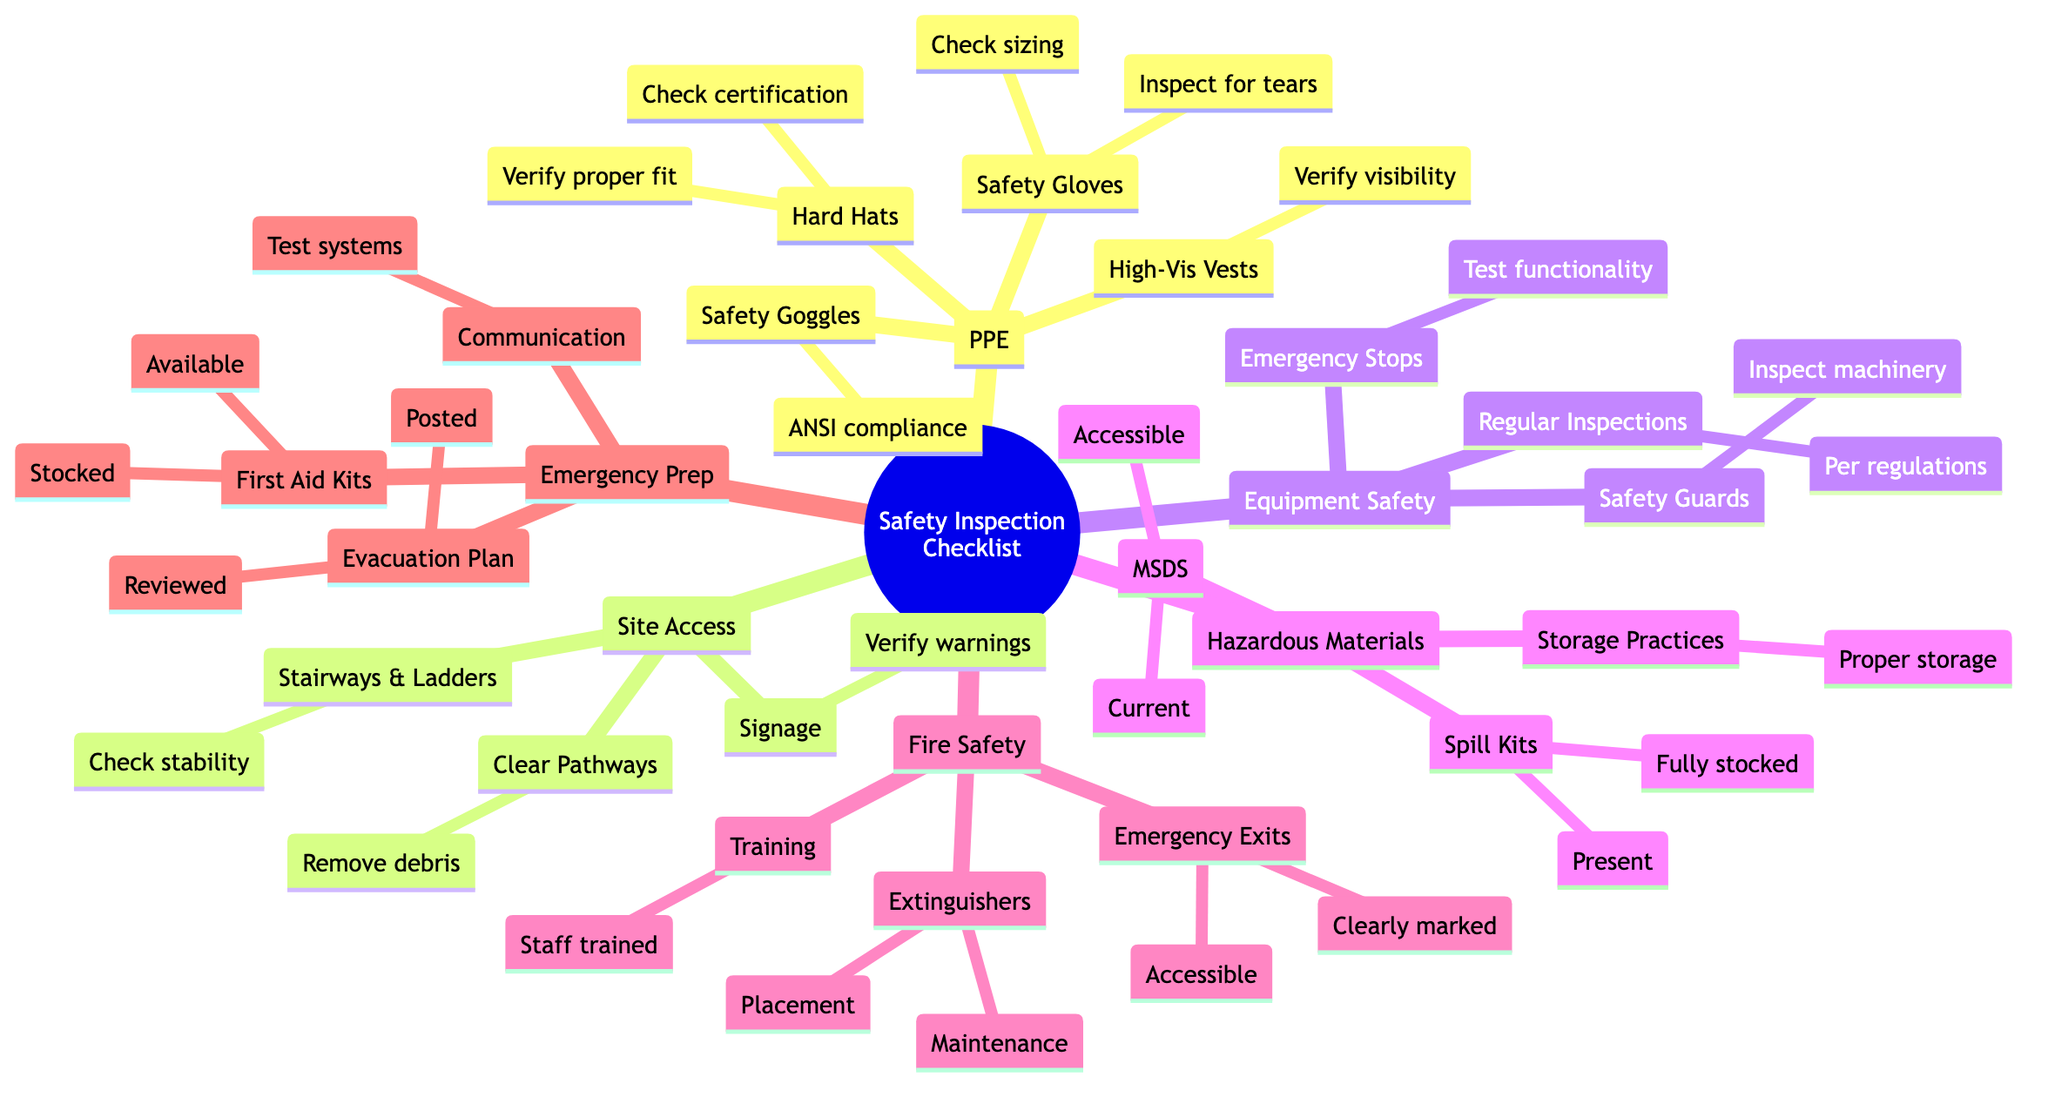What are the four main categories of the safety inspection checklist? The diagram lists the following main categories: Personal Protective Equipment, Site Access and Walkways, Equipment Safety, Hazardous Materials, Fire Safety, and Emergency Preparedness. These represent the top-level nodes of the mind map.
Answer: Personal Protective Equipment, Site Access and Walkways, Equipment Safety, Hazardous Materials, Fire Safety, Emergency Preparedness How many items are listed under Personal Protective Equipment? Under the category of Personal Protective Equipment, there are four specific items listed: Hard Hats, Safety Goggles, Safety Gloves, and High-Visibility Vests.
Answer: 4 What is checked for Hard Hats in the inspection? The inspection of Hard Hats involves two specific checks: checking for appropriate certification and verifying proper fit. These are the sub-items associated with this node in the diagram.
Answer: Check for appropriate certification and proper fit Which item under Emergency Preparedness ensures first aid supplies are ready? The First Aid Kits node under Emergency Preparedness specifically mentions checking that the kits are stocked and available on-site to ensure readiness for any incidents.
Answer: First Aid Kits Which safety measure is checked for its current condition regarding hazardous materials? The Material Safety Data Sheets (MSDS) node under Hazardous Materials emphasizes confirming that MSDS are accessible and current, which is essential for handling hazardous materials safely.
Answer: Confirm MSDS are accessible and current How many specific items fall under Fire Safety? Fire Safety has three specific sub-items: Fire Extinguishers, Emergency Exits, and Fire Safety Training. Thus, there are three items that focus on fire safety in the inspection checklist.
Answer: 3 What is the requirement for Stairways and Ladders in the site access section? The requirement for Stairways and Ladders states that a check for stability and absence of damage must be conducted, ensuring these are safe for use on-site.
Answer: Check stability and absence of damage What information is assessed regarding Emergency Stop Buttons? Emergency Stop Buttons require a test of functionality as part of the Equipment Safety checks, ensuring that machinery can be stopped in an emergency situation.
Answer: Test functionality of emergency stops What is the main focus of the Signage node in the Site Access category? The Signage node emphasizes verifying the presence of appropriate warning signs, which is crucial for informing workers and visitors of potential hazards at the site.
Answer: Verify the presence of appropriate warning signs 